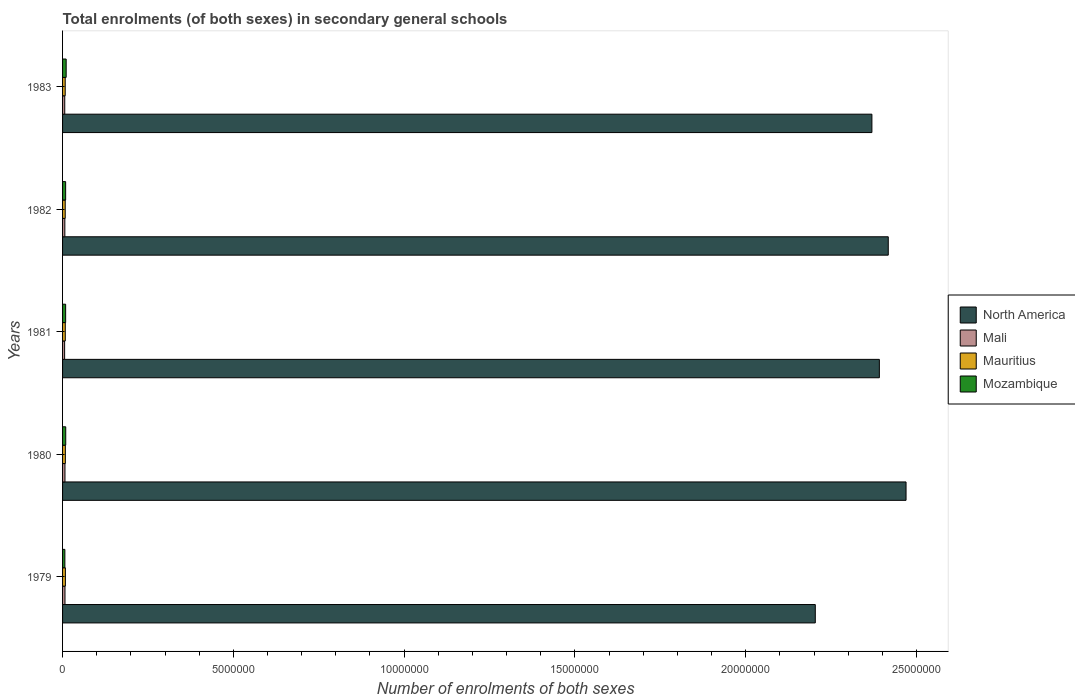How many groups of bars are there?
Offer a terse response. 5. How many bars are there on the 1st tick from the top?
Your answer should be compact. 4. What is the number of enrolments in secondary schools in Mauritius in 1982?
Keep it short and to the point. 7.74e+04. Across all years, what is the maximum number of enrolments in secondary schools in Mali?
Your response must be concise. 7.06e+04. Across all years, what is the minimum number of enrolments in secondary schools in Mauritius?
Provide a short and direct response. 7.72e+04. In which year was the number of enrolments in secondary schools in Mali maximum?
Offer a very short reply. 1979. What is the total number of enrolments in secondary schools in Mozambique in the graph?
Provide a succinct answer. 4.46e+05. What is the difference between the number of enrolments in secondary schools in North America in 1979 and that in 1981?
Give a very brief answer. -1.88e+06. What is the difference between the number of enrolments in secondary schools in Mozambique in 1979 and the number of enrolments in secondary schools in North America in 1983?
Ensure brevity in your answer.  -2.36e+07. What is the average number of enrolments in secondary schools in Mali per year?
Make the answer very short. 6.64e+04. In the year 1981, what is the difference between the number of enrolments in secondary schools in Mali and number of enrolments in secondary schools in Mozambique?
Give a very brief answer. -3.00e+04. In how many years, is the number of enrolments in secondary schools in Mozambique greater than 11000000 ?
Keep it short and to the point. 0. What is the ratio of the number of enrolments in secondary schools in Mali in 1980 to that in 1982?
Give a very brief answer. 1.06. What is the difference between the highest and the second highest number of enrolments in secondary schools in North America?
Your response must be concise. 5.21e+05. What is the difference between the highest and the lowest number of enrolments in secondary schools in North America?
Your answer should be very brief. 2.66e+06. Is the sum of the number of enrolments in secondary schools in Mauritius in 1981 and 1982 greater than the maximum number of enrolments in secondary schools in Mozambique across all years?
Provide a short and direct response. Yes. What does the 1st bar from the top in 1981 represents?
Your response must be concise. Mozambique. What does the 2nd bar from the bottom in 1981 represents?
Your response must be concise. Mali. Are all the bars in the graph horizontal?
Your response must be concise. Yes. How many years are there in the graph?
Provide a succinct answer. 5. What is the difference between two consecutive major ticks on the X-axis?
Offer a terse response. 5.00e+06. Are the values on the major ticks of X-axis written in scientific E-notation?
Ensure brevity in your answer.  No. Does the graph contain any zero values?
Give a very brief answer. No. Does the graph contain grids?
Offer a very short reply. No. How many legend labels are there?
Provide a short and direct response. 4. How are the legend labels stacked?
Your answer should be compact. Vertical. What is the title of the graph?
Your answer should be very brief. Total enrolments (of both sexes) in secondary general schools. What is the label or title of the X-axis?
Provide a succinct answer. Number of enrolments of both sexes. What is the label or title of the Y-axis?
Provide a short and direct response. Years. What is the Number of enrolments of both sexes in North America in 1979?
Your response must be concise. 2.20e+07. What is the Number of enrolments of both sexes of Mali in 1979?
Make the answer very short. 7.06e+04. What is the Number of enrolments of both sexes in Mauritius in 1979?
Provide a short and direct response. 8.26e+04. What is the Number of enrolments of both sexes in Mozambique in 1979?
Keep it short and to the point. 6.74e+04. What is the Number of enrolments of both sexes in North America in 1980?
Your response must be concise. 2.47e+07. What is the Number of enrolments of both sexes in Mali in 1980?
Keep it short and to the point. 7.05e+04. What is the Number of enrolments of both sexes in Mauritius in 1980?
Offer a very short reply. 8.17e+04. What is the Number of enrolments of both sexes of Mozambique in 1980?
Your answer should be very brief. 9.28e+04. What is the Number of enrolments of both sexes of North America in 1981?
Your response must be concise. 2.39e+07. What is the Number of enrolments of both sexes of Mali in 1981?
Keep it short and to the point. 6.01e+04. What is the Number of enrolments of both sexes of Mauritius in 1981?
Provide a succinct answer. 7.93e+04. What is the Number of enrolments of both sexes in Mozambique in 1981?
Your response must be concise. 9.00e+04. What is the Number of enrolments of both sexes in North America in 1982?
Give a very brief answer. 2.42e+07. What is the Number of enrolments of both sexes in Mali in 1982?
Ensure brevity in your answer.  6.67e+04. What is the Number of enrolments of both sexes in Mauritius in 1982?
Provide a short and direct response. 7.74e+04. What is the Number of enrolments of both sexes in Mozambique in 1982?
Your answer should be very brief. 8.98e+04. What is the Number of enrolments of both sexes in North America in 1983?
Offer a very short reply. 2.37e+07. What is the Number of enrolments of both sexes in Mali in 1983?
Make the answer very short. 6.41e+04. What is the Number of enrolments of both sexes in Mauritius in 1983?
Ensure brevity in your answer.  7.72e+04. What is the Number of enrolments of both sexes of Mozambique in 1983?
Ensure brevity in your answer.  1.05e+05. Across all years, what is the maximum Number of enrolments of both sexes of North America?
Offer a very short reply. 2.47e+07. Across all years, what is the maximum Number of enrolments of both sexes in Mali?
Provide a succinct answer. 7.06e+04. Across all years, what is the maximum Number of enrolments of both sexes of Mauritius?
Your answer should be very brief. 8.26e+04. Across all years, what is the maximum Number of enrolments of both sexes in Mozambique?
Give a very brief answer. 1.05e+05. Across all years, what is the minimum Number of enrolments of both sexes of North America?
Provide a short and direct response. 2.20e+07. Across all years, what is the minimum Number of enrolments of both sexes of Mali?
Give a very brief answer. 6.01e+04. Across all years, what is the minimum Number of enrolments of both sexes in Mauritius?
Make the answer very short. 7.72e+04. Across all years, what is the minimum Number of enrolments of both sexes of Mozambique?
Keep it short and to the point. 6.74e+04. What is the total Number of enrolments of both sexes in North America in the graph?
Give a very brief answer. 1.19e+08. What is the total Number of enrolments of both sexes of Mali in the graph?
Give a very brief answer. 3.32e+05. What is the total Number of enrolments of both sexes of Mauritius in the graph?
Give a very brief answer. 3.98e+05. What is the total Number of enrolments of both sexes in Mozambique in the graph?
Provide a short and direct response. 4.46e+05. What is the difference between the Number of enrolments of both sexes of North America in 1979 and that in 1980?
Make the answer very short. -2.66e+06. What is the difference between the Number of enrolments of both sexes in Mali in 1979 and that in 1980?
Provide a succinct answer. 111. What is the difference between the Number of enrolments of both sexes in Mauritius in 1979 and that in 1980?
Your answer should be compact. 960. What is the difference between the Number of enrolments of both sexes in Mozambique in 1979 and that in 1980?
Your response must be concise. -2.54e+04. What is the difference between the Number of enrolments of both sexes in North America in 1979 and that in 1981?
Make the answer very short. -1.88e+06. What is the difference between the Number of enrolments of both sexes in Mali in 1979 and that in 1981?
Keep it short and to the point. 1.06e+04. What is the difference between the Number of enrolments of both sexes of Mauritius in 1979 and that in 1981?
Provide a succinct answer. 3302. What is the difference between the Number of enrolments of both sexes of Mozambique in 1979 and that in 1981?
Provide a succinct answer. -2.26e+04. What is the difference between the Number of enrolments of both sexes of North America in 1979 and that in 1982?
Ensure brevity in your answer.  -2.14e+06. What is the difference between the Number of enrolments of both sexes of Mali in 1979 and that in 1982?
Your answer should be very brief. 3956. What is the difference between the Number of enrolments of both sexes in Mauritius in 1979 and that in 1982?
Your answer should be very brief. 5174. What is the difference between the Number of enrolments of both sexes in Mozambique in 1979 and that in 1982?
Your response must be concise. -2.24e+04. What is the difference between the Number of enrolments of both sexes in North America in 1979 and that in 1983?
Your answer should be very brief. -1.66e+06. What is the difference between the Number of enrolments of both sexes in Mali in 1979 and that in 1983?
Your answer should be compact. 6477. What is the difference between the Number of enrolments of both sexes of Mauritius in 1979 and that in 1983?
Ensure brevity in your answer.  5428. What is the difference between the Number of enrolments of both sexes in Mozambique in 1979 and that in 1983?
Keep it short and to the point. -3.80e+04. What is the difference between the Number of enrolments of both sexes in North America in 1980 and that in 1981?
Offer a very short reply. 7.81e+05. What is the difference between the Number of enrolments of both sexes of Mali in 1980 and that in 1981?
Offer a very short reply. 1.04e+04. What is the difference between the Number of enrolments of both sexes of Mauritius in 1980 and that in 1981?
Your response must be concise. 2342. What is the difference between the Number of enrolments of both sexes in Mozambique in 1980 and that in 1981?
Offer a terse response. 2774. What is the difference between the Number of enrolments of both sexes in North America in 1980 and that in 1982?
Offer a very short reply. 5.21e+05. What is the difference between the Number of enrolments of both sexes of Mali in 1980 and that in 1982?
Offer a terse response. 3845. What is the difference between the Number of enrolments of both sexes in Mauritius in 1980 and that in 1982?
Your response must be concise. 4214. What is the difference between the Number of enrolments of both sexes of Mozambique in 1980 and that in 1982?
Your answer should be very brief. 2980. What is the difference between the Number of enrolments of both sexes in North America in 1980 and that in 1983?
Your response must be concise. 1.00e+06. What is the difference between the Number of enrolments of both sexes in Mali in 1980 and that in 1983?
Make the answer very short. 6366. What is the difference between the Number of enrolments of both sexes of Mauritius in 1980 and that in 1983?
Your answer should be compact. 4468. What is the difference between the Number of enrolments of both sexes of Mozambique in 1980 and that in 1983?
Offer a very short reply. -1.26e+04. What is the difference between the Number of enrolments of both sexes of North America in 1981 and that in 1982?
Ensure brevity in your answer.  -2.61e+05. What is the difference between the Number of enrolments of both sexes in Mali in 1981 and that in 1982?
Ensure brevity in your answer.  -6604. What is the difference between the Number of enrolments of both sexes in Mauritius in 1981 and that in 1982?
Provide a short and direct response. 1872. What is the difference between the Number of enrolments of both sexes of Mozambique in 1981 and that in 1982?
Your response must be concise. 206. What is the difference between the Number of enrolments of both sexes in North America in 1981 and that in 1983?
Provide a succinct answer. 2.18e+05. What is the difference between the Number of enrolments of both sexes of Mali in 1981 and that in 1983?
Provide a short and direct response. -4083. What is the difference between the Number of enrolments of both sexes in Mauritius in 1981 and that in 1983?
Offer a very short reply. 2126. What is the difference between the Number of enrolments of both sexes in Mozambique in 1981 and that in 1983?
Your answer should be compact. -1.54e+04. What is the difference between the Number of enrolments of both sexes in North America in 1982 and that in 1983?
Offer a very short reply. 4.79e+05. What is the difference between the Number of enrolments of both sexes in Mali in 1982 and that in 1983?
Provide a short and direct response. 2521. What is the difference between the Number of enrolments of both sexes of Mauritius in 1982 and that in 1983?
Keep it short and to the point. 254. What is the difference between the Number of enrolments of both sexes of Mozambique in 1982 and that in 1983?
Keep it short and to the point. -1.56e+04. What is the difference between the Number of enrolments of both sexes of North America in 1979 and the Number of enrolments of both sexes of Mali in 1980?
Provide a succinct answer. 2.20e+07. What is the difference between the Number of enrolments of both sexes in North America in 1979 and the Number of enrolments of both sexes in Mauritius in 1980?
Make the answer very short. 2.20e+07. What is the difference between the Number of enrolments of both sexes in North America in 1979 and the Number of enrolments of both sexes in Mozambique in 1980?
Your response must be concise. 2.19e+07. What is the difference between the Number of enrolments of both sexes in Mali in 1979 and the Number of enrolments of both sexes in Mauritius in 1980?
Ensure brevity in your answer.  -1.10e+04. What is the difference between the Number of enrolments of both sexes of Mali in 1979 and the Number of enrolments of both sexes of Mozambique in 1980?
Offer a terse response. -2.22e+04. What is the difference between the Number of enrolments of both sexes in Mauritius in 1979 and the Number of enrolments of both sexes in Mozambique in 1980?
Give a very brief answer. -1.02e+04. What is the difference between the Number of enrolments of both sexes of North America in 1979 and the Number of enrolments of both sexes of Mali in 1981?
Your response must be concise. 2.20e+07. What is the difference between the Number of enrolments of both sexes of North America in 1979 and the Number of enrolments of both sexes of Mauritius in 1981?
Your response must be concise. 2.20e+07. What is the difference between the Number of enrolments of both sexes in North America in 1979 and the Number of enrolments of both sexes in Mozambique in 1981?
Give a very brief answer. 2.19e+07. What is the difference between the Number of enrolments of both sexes in Mali in 1979 and the Number of enrolments of both sexes in Mauritius in 1981?
Your response must be concise. -8689. What is the difference between the Number of enrolments of both sexes in Mali in 1979 and the Number of enrolments of both sexes in Mozambique in 1981?
Your answer should be very brief. -1.94e+04. What is the difference between the Number of enrolments of both sexes of Mauritius in 1979 and the Number of enrolments of both sexes of Mozambique in 1981?
Provide a succinct answer. -7425. What is the difference between the Number of enrolments of both sexes of North America in 1979 and the Number of enrolments of both sexes of Mali in 1982?
Your answer should be compact. 2.20e+07. What is the difference between the Number of enrolments of both sexes in North America in 1979 and the Number of enrolments of both sexes in Mauritius in 1982?
Provide a succinct answer. 2.20e+07. What is the difference between the Number of enrolments of both sexes in North America in 1979 and the Number of enrolments of both sexes in Mozambique in 1982?
Offer a very short reply. 2.19e+07. What is the difference between the Number of enrolments of both sexes of Mali in 1979 and the Number of enrolments of both sexes of Mauritius in 1982?
Provide a short and direct response. -6817. What is the difference between the Number of enrolments of both sexes of Mali in 1979 and the Number of enrolments of both sexes of Mozambique in 1982?
Your answer should be compact. -1.92e+04. What is the difference between the Number of enrolments of both sexes in Mauritius in 1979 and the Number of enrolments of both sexes in Mozambique in 1982?
Keep it short and to the point. -7219. What is the difference between the Number of enrolments of both sexes in North America in 1979 and the Number of enrolments of both sexes in Mali in 1983?
Your answer should be very brief. 2.20e+07. What is the difference between the Number of enrolments of both sexes of North America in 1979 and the Number of enrolments of both sexes of Mauritius in 1983?
Make the answer very short. 2.20e+07. What is the difference between the Number of enrolments of both sexes in North America in 1979 and the Number of enrolments of both sexes in Mozambique in 1983?
Offer a terse response. 2.19e+07. What is the difference between the Number of enrolments of both sexes in Mali in 1979 and the Number of enrolments of both sexes in Mauritius in 1983?
Your answer should be very brief. -6563. What is the difference between the Number of enrolments of both sexes in Mali in 1979 and the Number of enrolments of both sexes in Mozambique in 1983?
Ensure brevity in your answer.  -3.48e+04. What is the difference between the Number of enrolments of both sexes of Mauritius in 1979 and the Number of enrolments of both sexes of Mozambique in 1983?
Your response must be concise. -2.28e+04. What is the difference between the Number of enrolments of both sexes of North America in 1980 and the Number of enrolments of both sexes of Mali in 1981?
Your response must be concise. 2.46e+07. What is the difference between the Number of enrolments of both sexes in North America in 1980 and the Number of enrolments of both sexes in Mauritius in 1981?
Provide a short and direct response. 2.46e+07. What is the difference between the Number of enrolments of both sexes in North America in 1980 and the Number of enrolments of both sexes in Mozambique in 1981?
Keep it short and to the point. 2.46e+07. What is the difference between the Number of enrolments of both sexes in Mali in 1980 and the Number of enrolments of both sexes in Mauritius in 1981?
Offer a very short reply. -8800. What is the difference between the Number of enrolments of both sexes in Mali in 1980 and the Number of enrolments of both sexes in Mozambique in 1981?
Provide a succinct answer. -1.95e+04. What is the difference between the Number of enrolments of both sexes of Mauritius in 1980 and the Number of enrolments of both sexes of Mozambique in 1981?
Give a very brief answer. -8385. What is the difference between the Number of enrolments of both sexes in North America in 1980 and the Number of enrolments of both sexes in Mali in 1982?
Make the answer very short. 2.46e+07. What is the difference between the Number of enrolments of both sexes in North America in 1980 and the Number of enrolments of both sexes in Mauritius in 1982?
Ensure brevity in your answer.  2.46e+07. What is the difference between the Number of enrolments of both sexes of North America in 1980 and the Number of enrolments of both sexes of Mozambique in 1982?
Provide a short and direct response. 2.46e+07. What is the difference between the Number of enrolments of both sexes of Mali in 1980 and the Number of enrolments of both sexes of Mauritius in 1982?
Offer a terse response. -6928. What is the difference between the Number of enrolments of both sexes of Mali in 1980 and the Number of enrolments of both sexes of Mozambique in 1982?
Ensure brevity in your answer.  -1.93e+04. What is the difference between the Number of enrolments of both sexes in Mauritius in 1980 and the Number of enrolments of both sexes in Mozambique in 1982?
Keep it short and to the point. -8179. What is the difference between the Number of enrolments of both sexes of North America in 1980 and the Number of enrolments of both sexes of Mali in 1983?
Offer a terse response. 2.46e+07. What is the difference between the Number of enrolments of both sexes in North America in 1980 and the Number of enrolments of both sexes in Mauritius in 1983?
Make the answer very short. 2.46e+07. What is the difference between the Number of enrolments of both sexes of North America in 1980 and the Number of enrolments of both sexes of Mozambique in 1983?
Offer a terse response. 2.46e+07. What is the difference between the Number of enrolments of both sexes of Mali in 1980 and the Number of enrolments of both sexes of Mauritius in 1983?
Ensure brevity in your answer.  -6674. What is the difference between the Number of enrolments of both sexes of Mali in 1980 and the Number of enrolments of both sexes of Mozambique in 1983?
Your answer should be very brief. -3.49e+04. What is the difference between the Number of enrolments of both sexes in Mauritius in 1980 and the Number of enrolments of both sexes in Mozambique in 1983?
Your answer should be compact. -2.37e+04. What is the difference between the Number of enrolments of both sexes in North America in 1981 and the Number of enrolments of both sexes in Mali in 1982?
Your response must be concise. 2.38e+07. What is the difference between the Number of enrolments of both sexes of North America in 1981 and the Number of enrolments of both sexes of Mauritius in 1982?
Offer a terse response. 2.38e+07. What is the difference between the Number of enrolments of both sexes of North America in 1981 and the Number of enrolments of both sexes of Mozambique in 1982?
Keep it short and to the point. 2.38e+07. What is the difference between the Number of enrolments of both sexes of Mali in 1981 and the Number of enrolments of both sexes of Mauritius in 1982?
Offer a very short reply. -1.74e+04. What is the difference between the Number of enrolments of both sexes in Mali in 1981 and the Number of enrolments of both sexes in Mozambique in 1982?
Give a very brief answer. -2.98e+04. What is the difference between the Number of enrolments of both sexes of Mauritius in 1981 and the Number of enrolments of both sexes of Mozambique in 1982?
Make the answer very short. -1.05e+04. What is the difference between the Number of enrolments of both sexes of North America in 1981 and the Number of enrolments of both sexes of Mali in 1983?
Provide a short and direct response. 2.38e+07. What is the difference between the Number of enrolments of both sexes of North America in 1981 and the Number of enrolments of both sexes of Mauritius in 1983?
Your answer should be compact. 2.38e+07. What is the difference between the Number of enrolments of both sexes in North America in 1981 and the Number of enrolments of both sexes in Mozambique in 1983?
Give a very brief answer. 2.38e+07. What is the difference between the Number of enrolments of both sexes in Mali in 1981 and the Number of enrolments of both sexes in Mauritius in 1983?
Keep it short and to the point. -1.71e+04. What is the difference between the Number of enrolments of both sexes in Mali in 1981 and the Number of enrolments of both sexes in Mozambique in 1983?
Offer a very short reply. -4.53e+04. What is the difference between the Number of enrolments of both sexes of Mauritius in 1981 and the Number of enrolments of both sexes of Mozambique in 1983?
Your response must be concise. -2.61e+04. What is the difference between the Number of enrolments of both sexes in North America in 1982 and the Number of enrolments of both sexes in Mali in 1983?
Offer a very short reply. 2.41e+07. What is the difference between the Number of enrolments of both sexes of North America in 1982 and the Number of enrolments of both sexes of Mauritius in 1983?
Provide a succinct answer. 2.41e+07. What is the difference between the Number of enrolments of both sexes in North America in 1982 and the Number of enrolments of both sexes in Mozambique in 1983?
Your answer should be very brief. 2.41e+07. What is the difference between the Number of enrolments of both sexes of Mali in 1982 and the Number of enrolments of both sexes of Mauritius in 1983?
Your answer should be very brief. -1.05e+04. What is the difference between the Number of enrolments of both sexes in Mali in 1982 and the Number of enrolments of both sexes in Mozambique in 1983?
Offer a terse response. -3.87e+04. What is the difference between the Number of enrolments of both sexes in Mauritius in 1982 and the Number of enrolments of both sexes in Mozambique in 1983?
Provide a short and direct response. -2.80e+04. What is the average Number of enrolments of both sexes of North America per year?
Keep it short and to the point. 2.37e+07. What is the average Number of enrolments of both sexes of Mali per year?
Your response must be concise. 6.64e+04. What is the average Number of enrolments of both sexes in Mauritius per year?
Provide a succinct answer. 7.96e+04. What is the average Number of enrolments of both sexes of Mozambique per year?
Your answer should be compact. 8.91e+04. In the year 1979, what is the difference between the Number of enrolments of both sexes in North America and Number of enrolments of both sexes in Mali?
Offer a very short reply. 2.20e+07. In the year 1979, what is the difference between the Number of enrolments of both sexes in North America and Number of enrolments of both sexes in Mauritius?
Make the answer very short. 2.20e+07. In the year 1979, what is the difference between the Number of enrolments of both sexes in North America and Number of enrolments of both sexes in Mozambique?
Your answer should be very brief. 2.20e+07. In the year 1979, what is the difference between the Number of enrolments of both sexes of Mali and Number of enrolments of both sexes of Mauritius?
Provide a succinct answer. -1.20e+04. In the year 1979, what is the difference between the Number of enrolments of both sexes of Mali and Number of enrolments of both sexes of Mozambique?
Offer a very short reply. 3209. In the year 1979, what is the difference between the Number of enrolments of both sexes of Mauritius and Number of enrolments of both sexes of Mozambique?
Make the answer very short. 1.52e+04. In the year 1980, what is the difference between the Number of enrolments of both sexes in North America and Number of enrolments of both sexes in Mali?
Your answer should be compact. 2.46e+07. In the year 1980, what is the difference between the Number of enrolments of both sexes of North America and Number of enrolments of both sexes of Mauritius?
Your answer should be compact. 2.46e+07. In the year 1980, what is the difference between the Number of enrolments of both sexes in North America and Number of enrolments of both sexes in Mozambique?
Ensure brevity in your answer.  2.46e+07. In the year 1980, what is the difference between the Number of enrolments of both sexes of Mali and Number of enrolments of both sexes of Mauritius?
Provide a short and direct response. -1.11e+04. In the year 1980, what is the difference between the Number of enrolments of both sexes in Mali and Number of enrolments of both sexes in Mozambique?
Keep it short and to the point. -2.23e+04. In the year 1980, what is the difference between the Number of enrolments of both sexes in Mauritius and Number of enrolments of both sexes in Mozambique?
Keep it short and to the point. -1.12e+04. In the year 1981, what is the difference between the Number of enrolments of both sexes in North America and Number of enrolments of both sexes in Mali?
Provide a short and direct response. 2.39e+07. In the year 1981, what is the difference between the Number of enrolments of both sexes in North America and Number of enrolments of both sexes in Mauritius?
Your answer should be compact. 2.38e+07. In the year 1981, what is the difference between the Number of enrolments of both sexes in North America and Number of enrolments of both sexes in Mozambique?
Make the answer very short. 2.38e+07. In the year 1981, what is the difference between the Number of enrolments of both sexes of Mali and Number of enrolments of both sexes of Mauritius?
Provide a succinct answer. -1.92e+04. In the year 1981, what is the difference between the Number of enrolments of both sexes of Mali and Number of enrolments of both sexes of Mozambique?
Offer a terse response. -3.00e+04. In the year 1981, what is the difference between the Number of enrolments of both sexes of Mauritius and Number of enrolments of both sexes of Mozambique?
Offer a terse response. -1.07e+04. In the year 1982, what is the difference between the Number of enrolments of both sexes of North America and Number of enrolments of both sexes of Mali?
Give a very brief answer. 2.41e+07. In the year 1982, what is the difference between the Number of enrolments of both sexes of North America and Number of enrolments of both sexes of Mauritius?
Your answer should be compact. 2.41e+07. In the year 1982, what is the difference between the Number of enrolments of both sexes of North America and Number of enrolments of both sexes of Mozambique?
Provide a succinct answer. 2.41e+07. In the year 1982, what is the difference between the Number of enrolments of both sexes of Mali and Number of enrolments of both sexes of Mauritius?
Your answer should be very brief. -1.08e+04. In the year 1982, what is the difference between the Number of enrolments of both sexes of Mali and Number of enrolments of both sexes of Mozambique?
Make the answer very short. -2.32e+04. In the year 1982, what is the difference between the Number of enrolments of both sexes in Mauritius and Number of enrolments of both sexes in Mozambique?
Your answer should be compact. -1.24e+04. In the year 1983, what is the difference between the Number of enrolments of both sexes in North America and Number of enrolments of both sexes in Mali?
Your answer should be compact. 2.36e+07. In the year 1983, what is the difference between the Number of enrolments of both sexes in North America and Number of enrolments of both sexes in Mauritius?
Ensure brevity in your answer.  2.36e+07. In the year 1983, what is the difference between the Number of enrolments of both sexes of North America and Number of enrolments of both sexes of Mozambique?
Keep it short and to the point. 2.36e+07. In the year 1983, what is the difference between the Number of enrolments of both sexes in Mali and Number of enrolments of both sexes in Mauritius?
Your answer should be very brief. -1.30e+04. In the year 1983, what is the difference between the Number of enrolments of both sexes in Mali and Number of enrolments of both sexes in Mozambique?
Make the answer very short. -4.12e+04. In the year 1983, what is the difference between the Number of enrolments of both sexes in Mauritius and Number of enrolments of both sexes in Mozambique?
Your response must be concise. -2.82e+04. What is the ratio of the Number of enrolments of both sexes of North America in 1979 to that in 1980?
Offer a terse response. 0.89. What is the ratio of the Number of enrolments of both sexes of Mali in 1979 to that in 1980?
Your response must be concise. 1. What is the ratio of the Number of enrolments of both sexes of Mauritius in 1979 to that in 1980?
Give a very brief answer. 1.01. What is the ratio of the Number of enrolments of both sexes in Mozambique in 1979 to that in 1980?
Make the answer very short. 0.73. What is the ratio of the Number of enrolments of both sexes of North America in 1979 to that in 1981?
Provide a succinct answer. 0.92. What is the ratio of the Number of enrolments of both sexes in Mali in 1979 to that in 1981?
Offer a terse response. 1.18. What is the ratio of the Number of enrolments of both sexes in Mauritius in 1979 to that in 1981?
Offer a very short reply. 1.04. What is the ratio of the Number of enrolments of both sexes in Mozambique in 1979 to that in 1981?
Offer a very short reply. 0.75. What is the ratio of the Number of enrolments of both sexes of North America in 1979 to that in 1982?
Keep it short and to the point. 0.91. What is the ratio of the Number of enrolments of both sexes of Mali in 1979 to that in 1982?
Keep it short and to the point. 1.06. What is the ratio of the Number of enrolments of both sexes of Mauritius in 1979 to that in 1982?
Ensure brevity in your answer.  1.07. What is the ratio of the Number of enrolments of both sexes in Mozambique in 1979 to that in 1982?
Your answer should be compact. 0.75. What is the ratio of the Number of enrolments of both sexes in North America in 1979 to that in 1983?
Your response must be concise. 0.93. What is the ratio of the Number of enrolments of both sexes of Mali in 1979 to that in 1983?
Provide a succinct answer. 1.1. What is the ratio of the Number of enrolments of both sexes in Mauritius in 1979 to that in 1983?
Keep it short and to the point. 1.07. What is the ratio of the Number of enrolments of both sexes of Mozambique in 1979 to that in 1983?
Keep it short and to the point. 0.64. What is the ratio of the Number of enrolments of both sexes of North America in 1980 to that in 1981?
Ensure brevity in your answer.  1.03. What is the ratio of the Number of enrolments of both sexes in Mali in 1980 to that in 1981?
Offer a very short reply. 1.17. What is the ratio of the Number of enrolments of both sexes of Mauritius in 1980 to that in 1981?
Offer a very short reply. 1.03. What is the ratio of the Number of enrolments of both sexes of Mozambique in 1980 to that in 1981?
Offer a very short reply. 1.03. What is the ratio of the Number of enrolments of both sexes of North America in 1980 to that in 1982?
Provide a succinct answer. 1.02. What is the ratio of the Number of enrolments of both sexes of Mali in 1980 to that in 1982?
Provide a succinct answer. 1.06. What is the ratio of the Number of enrolments of both sexes in Mauritius in 1980 to that in 1982?
Your answer should be compact. 1.05. What is the ratio of the Number of enrolments of both sexes in Mozambique in 1980 to that in 1982?
Provide a short and direct response. 1.03. What is the ratio of the Number of enrolments of both sexes of North America in 1980 to that in 1983?
Offer a terse response. 1.04. What is the ratio of the Number of enrolments of both sexes in Mali in 1980 to that in 1983?
Your response must be concise. 1.1. What is the ratio of the Number of enrolments of both sexes of Mauritius in 1980 to that in 1983?
Keep it short and to the point. 1.06. What is the ratio of the Number of enrolments of both sexes of Mozambique in 1980 to that in 1983?
Provide a succinct answer. 0.88. What is the ratio of the Number of enrolments of both sexes in Mali in 1981 to that in 1982?
Ensure brevity in your answer.  0.9. What is the ratio of the Number of enrolments of both sexes in Mauritius in 1981 to that in 1982?
Provide a succinct answer. 1.02. What is the ratio of the Number of enrolments of both sexes of North America in 1981 to that in 1983?
Make the answer very short. 1.01. What is the ratio of the Number of enrolments of both sexes of Mali in 1981 to that in 1983?
Ensure brevity in your answer.  0.94. What is the ratio of the Number of enrolments of both sexes of Mauritius in 1981 to that in 1983?
Offer a terse response. 1.03. What is the ratio of the Number of enrolments of both sexes in Mozambique in 1981 to that in 1983?
Make the answer very short. 0.85. What is the ratio of the Number of enrolments of both sexes in North America in 1982 to that in 1983?
Make the answer very short. 1.02. What is the ratio of the Number of enrolments of both sexes of Mali in 1982 to that in 1983?
Offer a terse response. 1.04. What is the ratio of the Number of enrolments of both sexes of Mozambique in 1982 to that in 1983?
Offer a terse response. 0.85. What is the difference between the highest and the second highest Number of enrolments of both sexes of North America?
Make the answer very short. 5.21e+05. What is the difference between the highest and the second highest Number of enrolments of both sexes in Mali?
Your answer should be very brief. 111. What is the difference between the highest and the second highest Number of enrolments of both sexes of Mauritius?
Ensure brevity in your answer.  960. What is the difference between the highest and the second highest Number of enrolments of both sexes of Mozambique?
Offer a very short reply. 1.26e+04. What is the difference between the highest and the lowest Number of enrolments of both sexes of North America?
Your answer should be compact. 2.66e+06. What is the difference between the highest and the lowest Number of enrolments of both sexes of Mali?
Your response must be concise. 1.06e+04. What is the difference between the highest and the lowest Number of enrolments of both sexes in Mauritius?
Your response must be concise. 5428. What is the difference between the highest and the lowest Number of enrolments of both sexes of Mozambique?
Your response must be concise. 3.80e+04. 